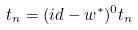Convert formula to latex. <formula><loc_0><loc_0><loc_500><loc_500>t _ { n } = ( i d - w ^ { \ast } ) ^ { 0 } t _ { n }</formula> 